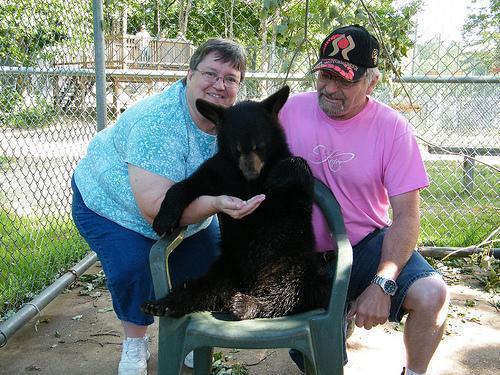How many people are photographed?
Give a very brief answer. 2. 